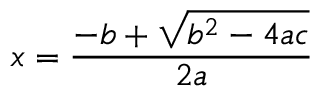<formula> <loc_0><loc_0><loc_500><loc_500>x = { \frac { - b + { \sqrt { b ^ { 2 } - 4 a c } } } { 2 a } }</formula> 